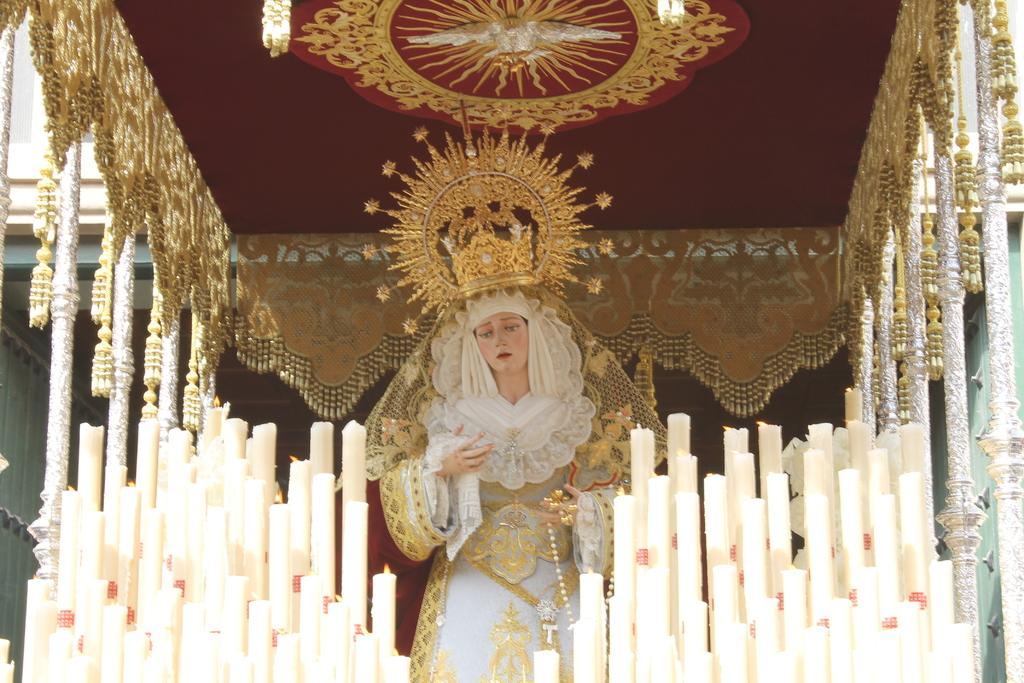What is the main subject in the center of the image? There is a statue in the center of the image. What can be seen in the background of the image? There are lighted candles and a decorative arch in the background. What is the decorative arch made of? The decorative arch has lights at the top, but the material is not specified in the facts. What is visible behind the statue? There is a wall visible in the image. What type of metal is used to create the territory in the image? There is no mention of a territory or metal in the image; it features a statue, lighted candles, a decorative arch, and a wall. 